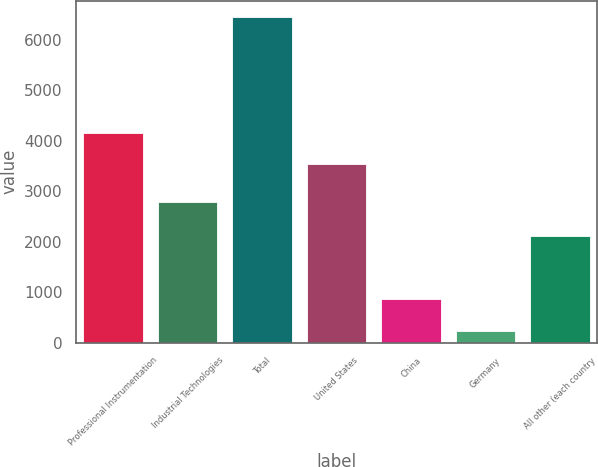Convert chart. <chart><loc_0><loc_0><loc_500><loc_500><bar_chart><fcel>Professional Instrumentation<fcel>Industrial Technologies<fcel>Total<fcel>United States<fcel>China<fcel>Germany<fcel>All other (each country<nl><fcel>4161.4<fcel>2797.6<fcel>6452.7<fcel>3539.6<fcel>856.5<fcel>234.7<fcel>2109.4<nl></chart> 